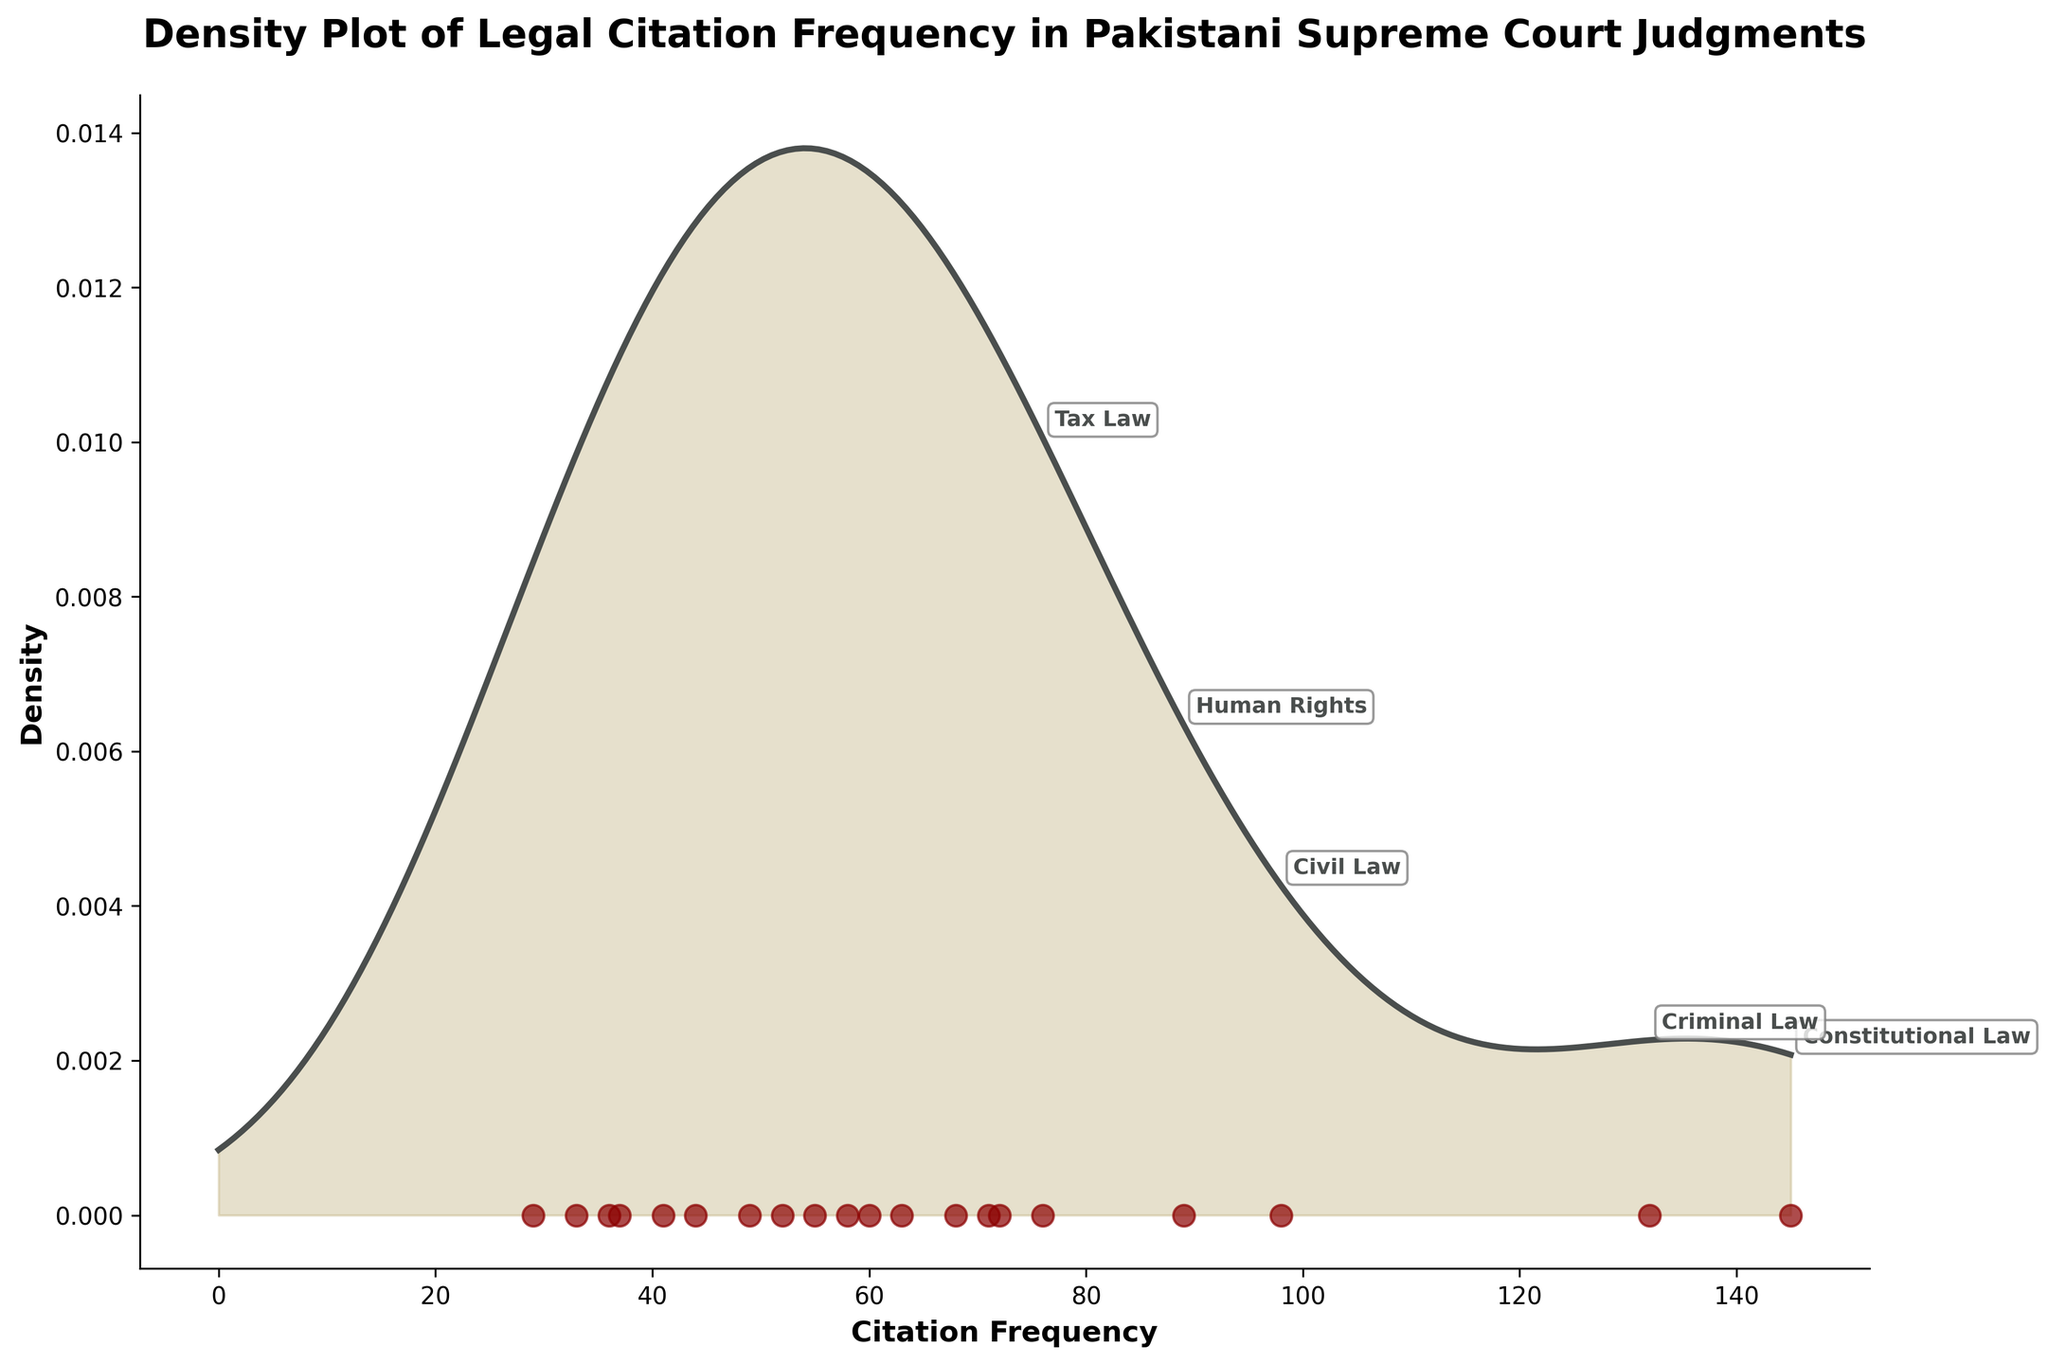What is the title of the plot? The title is the text that is located at the top of the plot and describes the main content of the figure. It reads: "Density Plot of Legal Citation Frequency in Pakistani Supreme Court Judgments".
Answer: Density Plot of Legal Citation Frequency in Pakistani Supreme Court Judgments Which subject area has the highest citation frequency? To determine the highest citation frequency, look for the peak of the scatter plots and the density curve. The subject area with the highest frequency will be annotated in the plot. The highest annotation indicates "Constitutional Law" with a frequency of 145.
Answer: Constitutional Law How many subject areas have a citation frequency between 50 and 100? To answer this, count the points on the x-axis that fall within the 50 to 100 range. The points corresponding to frequencies within this range are for Civil Law, Family Law, Labor Law, Property Law, Contract Law, Banking Law, and Islamic Law.
Answer: 7 Which subject area has the lowest citation frequency? Find the subject area with the point farthest to the left on the x-axis (indicating the smallest citation frequency), which is annotated as "Media Law" with a frequency of 29.
Answer: Media Law What is the frequency of citations for Environmental Law? Locate the position of "Environmental Law" among the scatter plots on the x-axis. The frequency is marked at the x-coordinate for Environmental Law, which is 44.
Answer: 44 What is the average citation frequency? Sum all the citation frequencies and divide by the number of subject areas. (145 + 132 + 98 + 76 + 63 + 55 + 89 + 71 + 52 + 44 + 68 + 37 + 49 + 41 + 58 + 33 + 60 + 72 + 29 + 36) / 20.
Answer: 67 Which subject area has the closest citation frequency to the mean citation frequency? Calculate the citation frequencies and compare each to the mean (67). The closest round to the mean is "Islamic Law" with a frequency of 72.
Answer: Islamic Law Between Criminal Law and Civil Law, which has a higher density at its citation frequency? Check the density curve at the citation frequencies of 132 (Criminal Law) and 98 (Civil Law). The plot shows that the density of Criminal Law is higher at its frequency point compared to Civil Law.
Answer: Criminal Law What is the range of citation frequencies? The range is the difference between the highest and lowest citation frequencies. Highest is 145 (Constitutional Law) and lowest is 29 (Media Law). Range = 145 - 29.
Answer: 116 Are there more subject areas with citation frequencies below 50 or above 100? Count the subject areas with frequencies below 50 and those above 100. Below 50 are 5 (Intellectual Property, Media Law, Energy Law, Tort Law, Environmental Law); above 100 are 2 (Constitutional Law, Criminal Law).
Answer: Below 50 